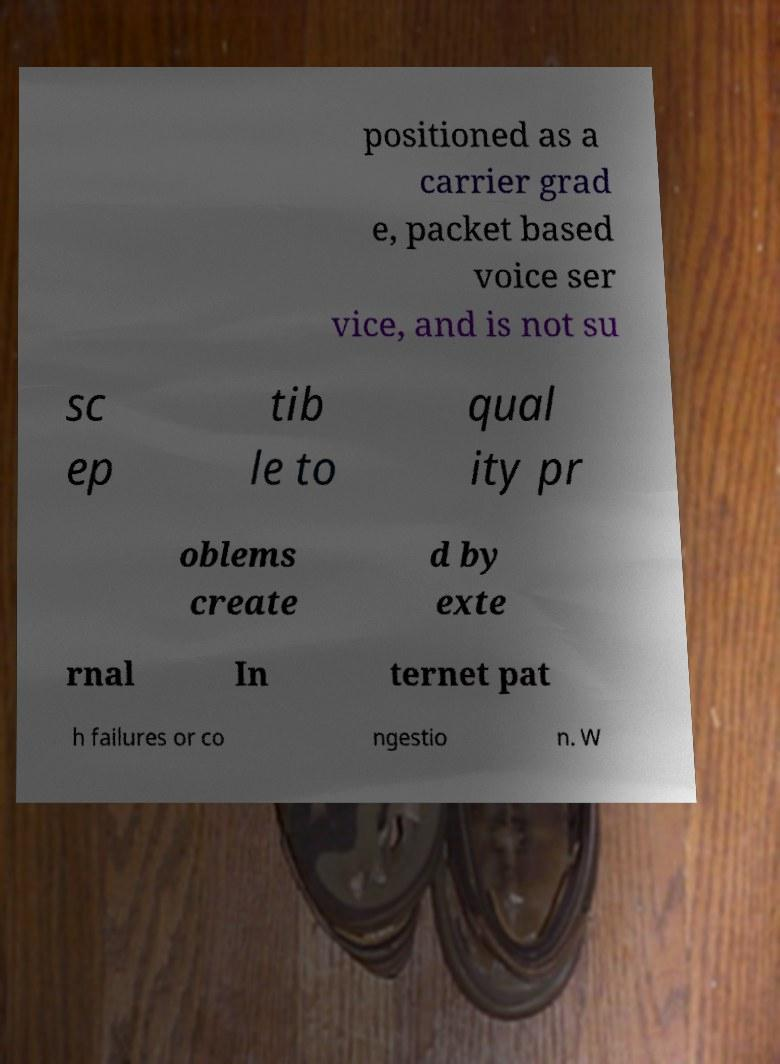Please identify and transcribe the text found in this image. positioned as a carrier grad e, packet based voice ser vice, and is not su sc ep tib le to qual ity pr oblems create d by exte rnal In ternet pat h failures or co ngestio n. W 